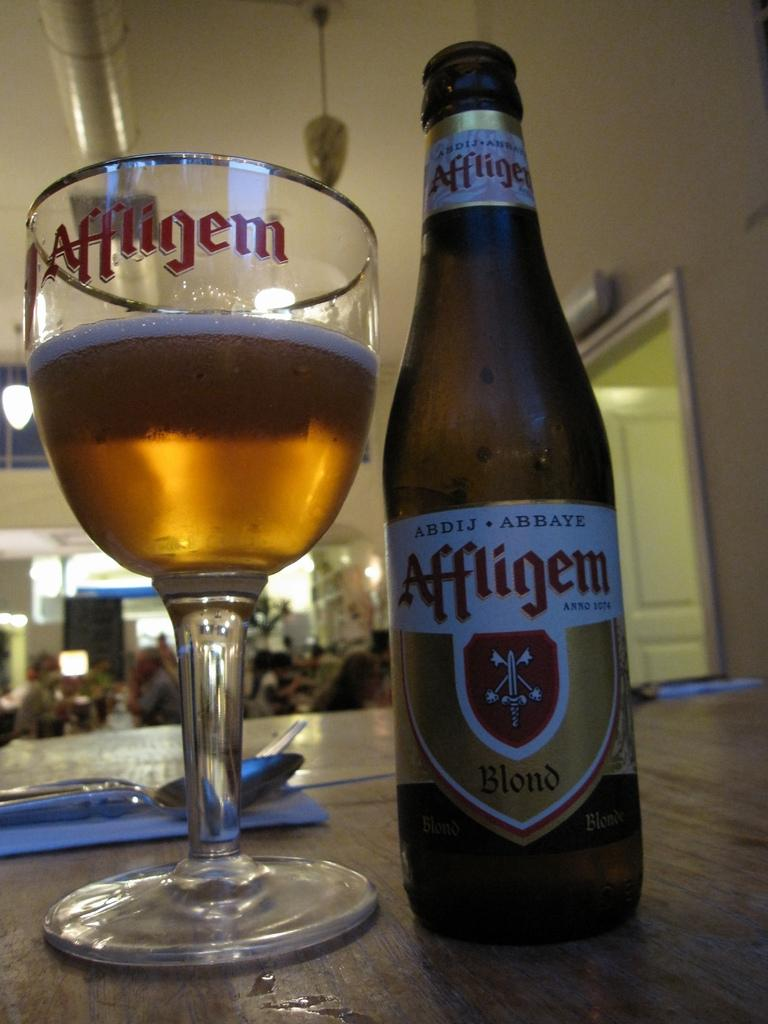Provide a one-sentence caption for the provided image. An Affligem bottle sits next to a glass on a table. 